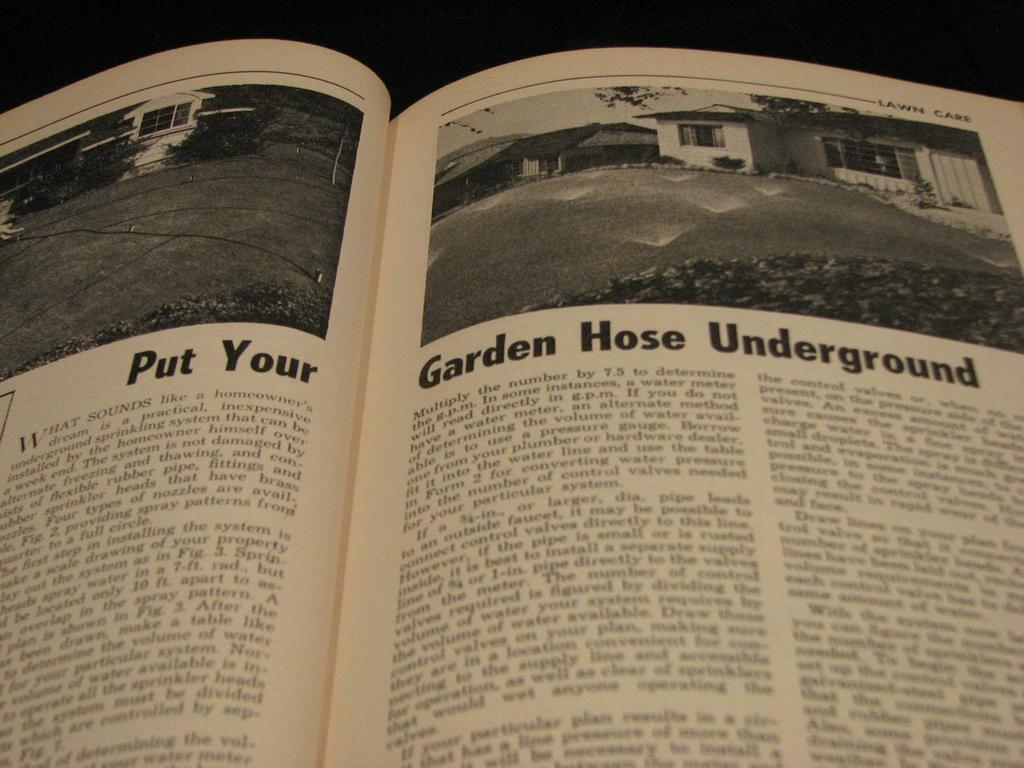<image>
Offer a succinct explanation of the picture presented. A book us open to pages about putting a garden hose underground. 